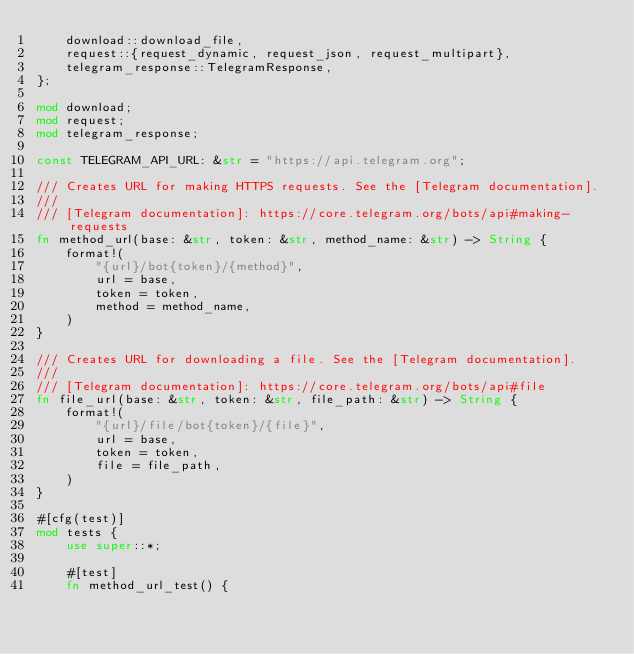Convert code to text. <code><loc_0><loc_0><loc_500><loc_500><_Rust_>    download::download_file,
    request::{request_dynamic, request_json, request_multipart},
    telegram_response::TelegramResponse,
};

mod download;
mod request;
mod telegram_response;

const TELEGRAM_API_URL: &str = "https://api.telegram.org";

/// Creates URL for making HTTPS requests. See the [Telegram documentation].
///
/// [Telegram documentation]: https://core.telegram.org/bots/api#making-requests
fn method_url(base: &str, token: &str, method_name: &str) -> String {
    format!(
        "{url}/bot{token}/{method}",
        url = base,
        token = token,
        method = method_name,
    )
}

/// Creates URL for downloading a file. See the [Telegram documentation].
///
/// [Telegram documentation]: https://core.telegram.org/bots/api#file
fn file_url(base: &str, token: &str, file_path: &str) -> String {
    format!(
        "{url}/file/bot{token}/{file}",
        url = base,
        token = token,
        file = file_path,
    )
}

#[cfg(test)]
mod tests {
    use super::*;

    #[test]
    fn method_url_test() {</code> 